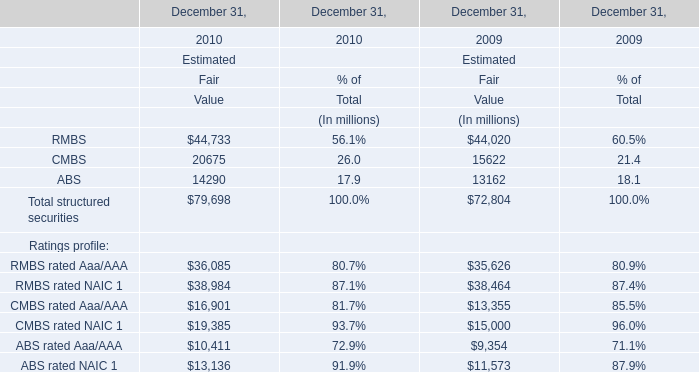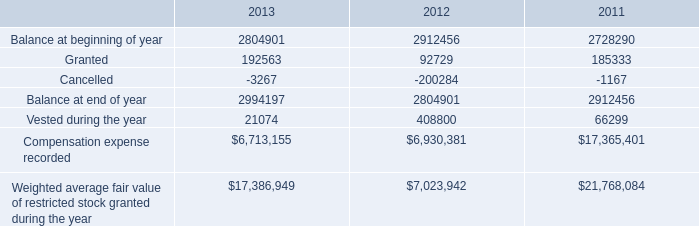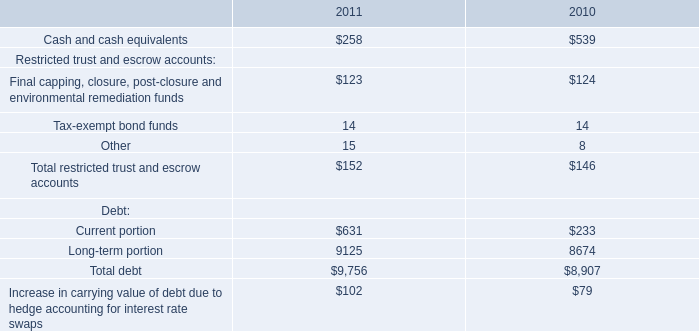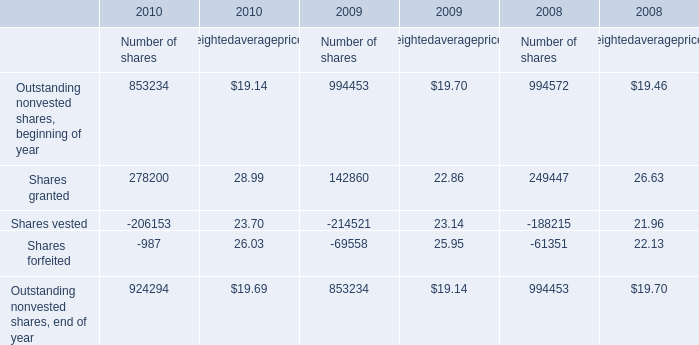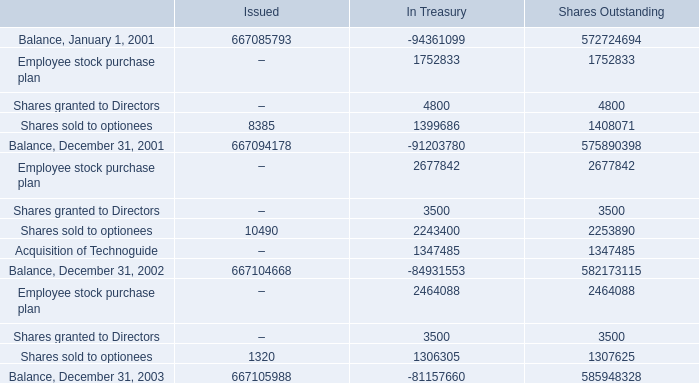In the year with largest amount of RMBS rated Aaa/AAA, what's the increasing rate of RMBS rated NAIC 1? 
Computations: ((38984 - 38464) / 38464)
Answer: 0.01352. 